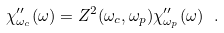<formula> <loc_0><loc_0><loc_500><loc_500>\chi _ { \omega _ { c } } ^ { \prime \prime } ( \omega ) = Z ^ { 2 } ( \omega _ { c } , \omega _ { p } ) \chi _ { \omega _ { p } } ^ { \prime \prime } ( \omega ) \ .</formula> 